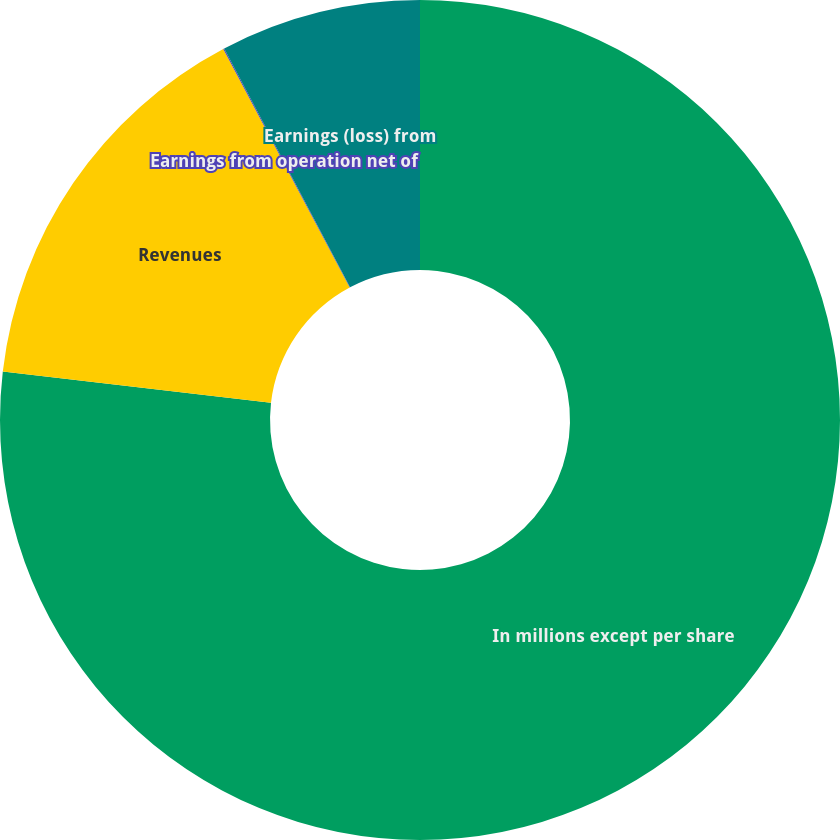Convert chart. <chart><loc_0><loc_0><loc_500><loc_500><pie_chart><fcel>In millions except per share<fcel>Revenues<fcel>Earnings from operation net of<fcel>Earnings (loss) from<nl><fcel>76.84%<fcel>15.4%<fcel>0.04%<fcel>7.72%<nl></chart> 